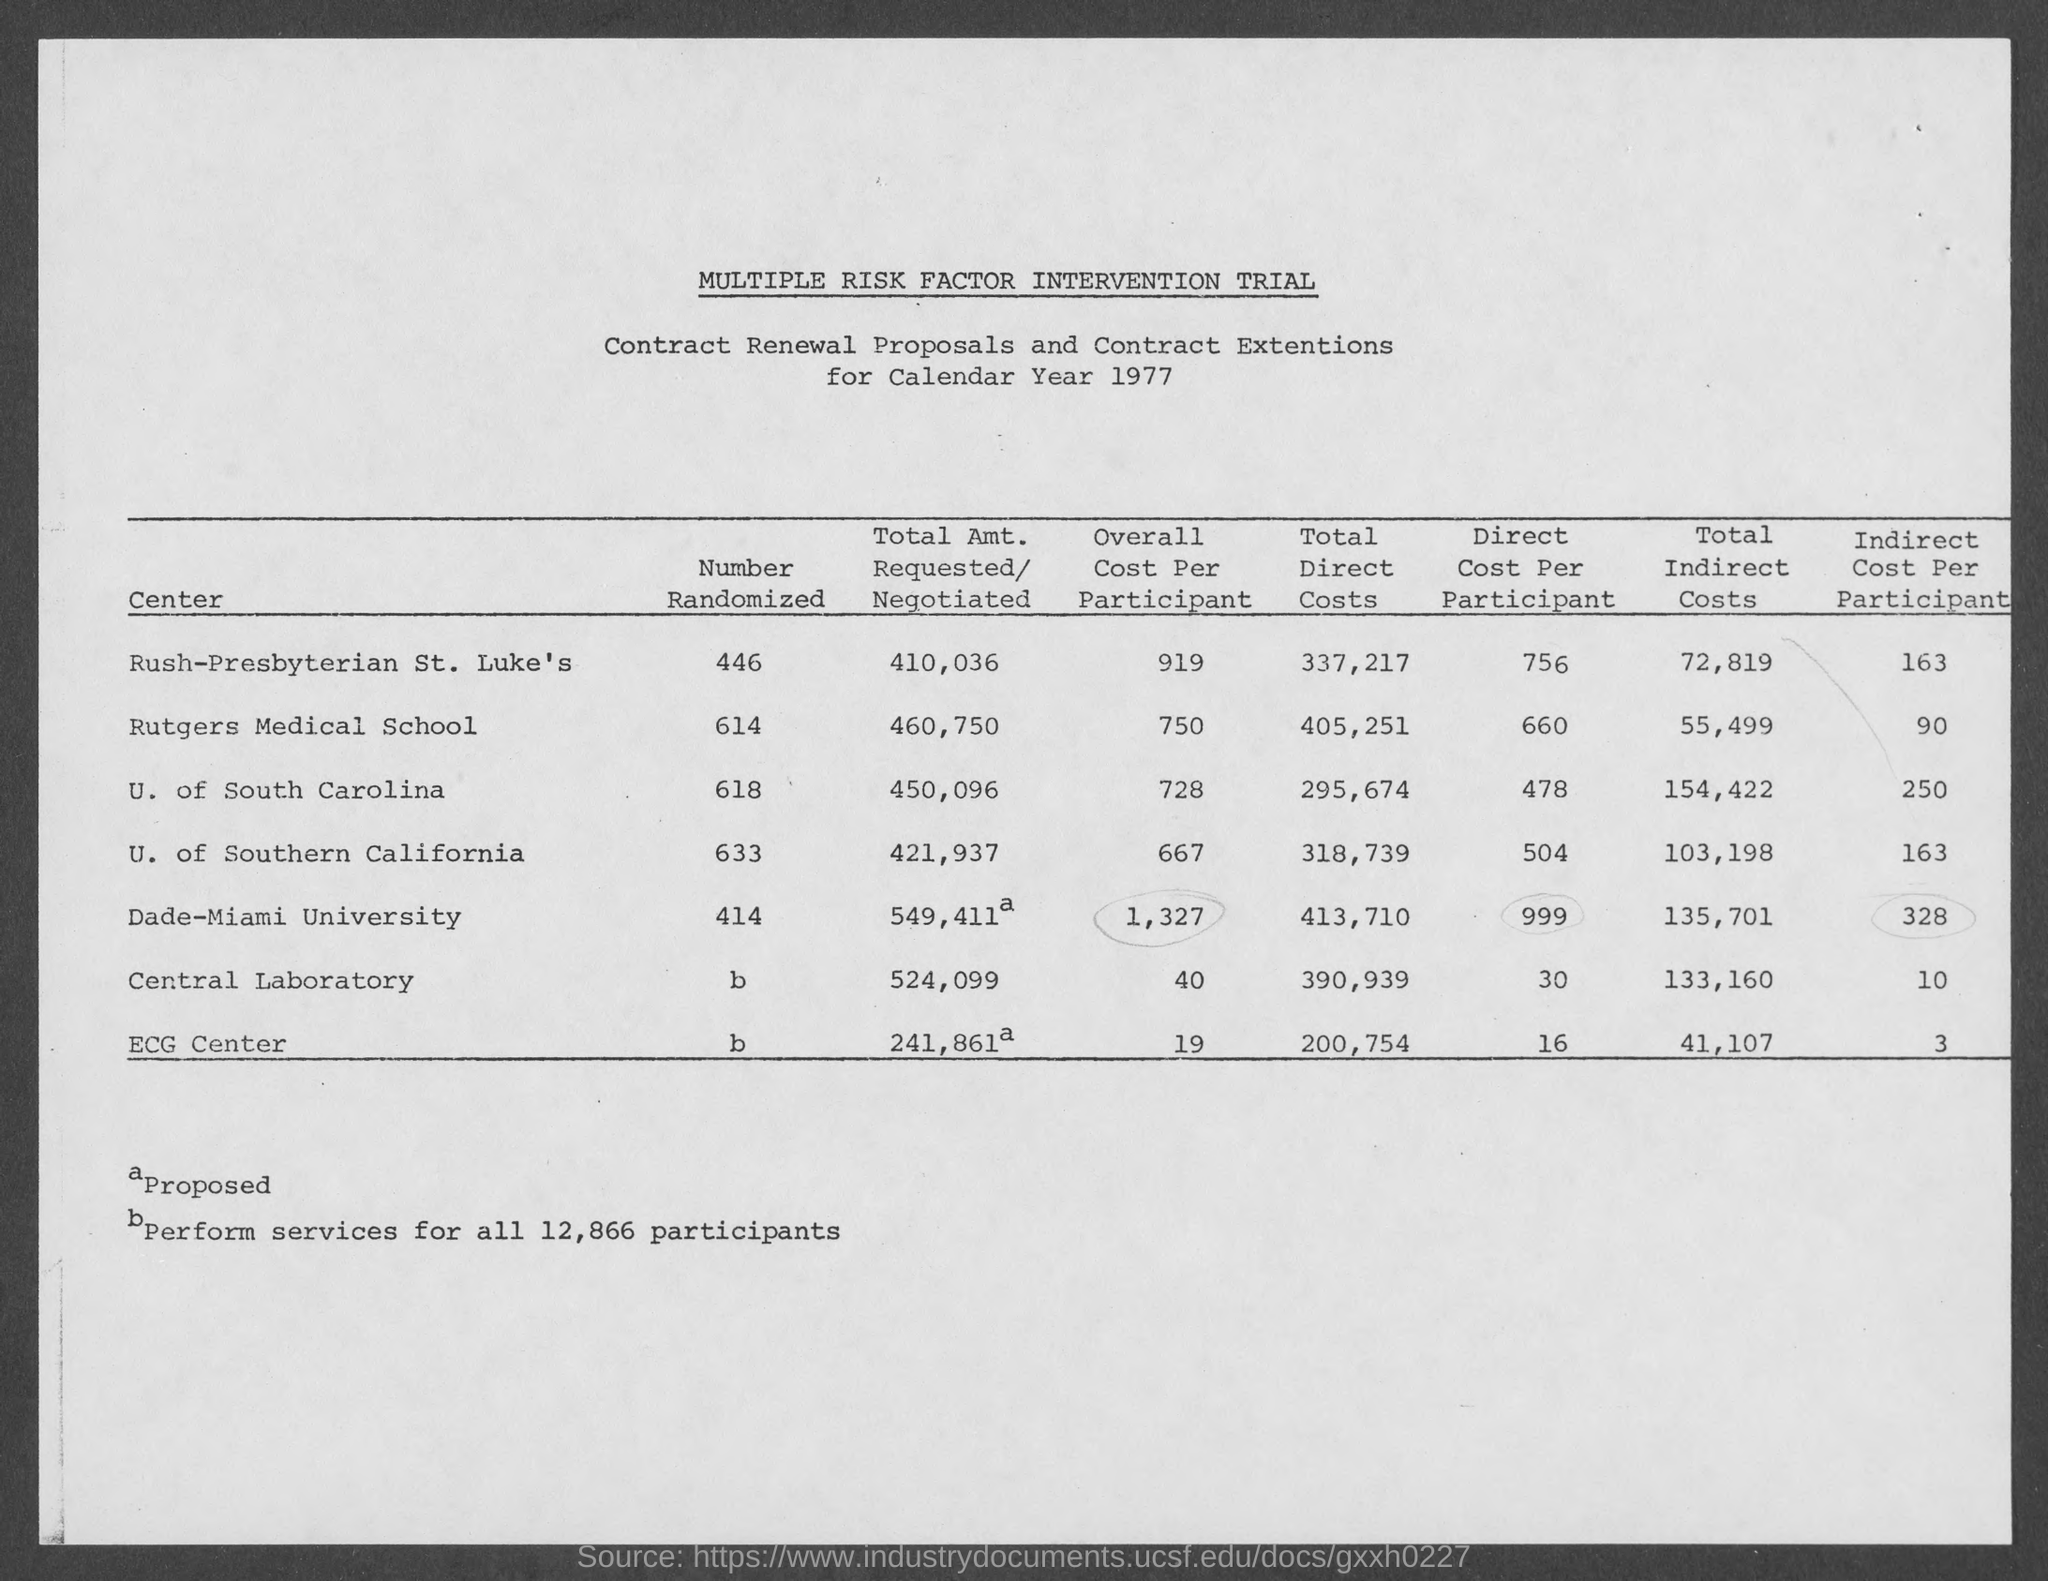What is the first title in the document?
Ensure brevity in your answer.  Multiple Risk Factor Intervention Trial. What is the number of randomized ECG centers?
Provide a short and direct response. B. What is the number of "randomized central laboratory"?
Keep it short and to the point. B. What is the year mentioned in the document?
Your answer should be compact. 1977. What is the total indirect cost for the ECG center?
Provide a succinct answer. 41,107. What is the total direct cost for the ECG center?
Make the answer very short. 200,754. What is the total direct cost for the central laboratory?
Ensure brevity in your answer.  390,939. 